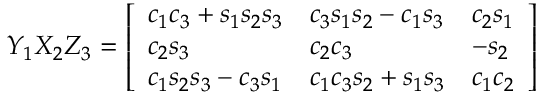<formula> <loc_0><loc_0><loc_500><loc_500>Y _ { 1 } X _ { 2 } Z _ { 3 } = { \left [ \begin{array} { l l l } { c _ { 1 } c _ { 3 } + s _ { 1 } s _ { 2 } s _ { 3 } } & { c _ { 3 } s _ { 1 } s _ { 2 } - c _ { 1 } s _ { 3 } } & { c _ { 2 } s _ { 1 } } \\ { c _ { 2 } s _ { 3 } } & { c _ { 2 } c _ { 3 } } & { - s _ { 2 } } \\ { c _ { 1 } s _ { 2 } s _ { 3 } - c _ { 3 } s _ { 1 } } & { c _ { 1 } c _ { 3 } s _ { 2 } + s _ { 1 } s _ { 3 } } & { c _ { 1 } c _ { 2 } } \end{array} \right ] }</formula> 